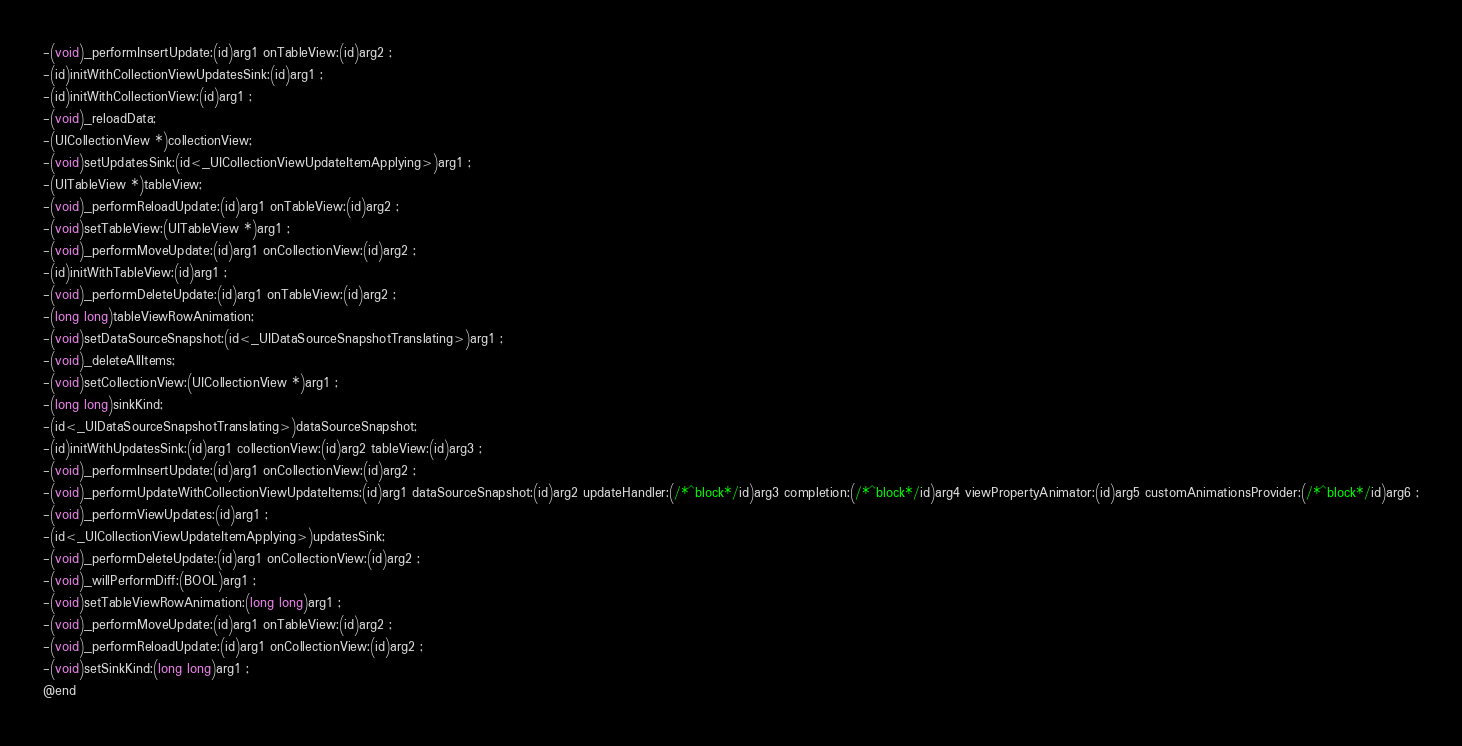Convert code to text. <code><loc_0><loc_0><loc_500><loc_500><_C_>-(void)_performInsertUpdate:(id)arg1 onTableView:(id)arg2 ;
-(id)initWithCollectionViewUpdatesSink:(id)arg1 ;
-(id)initWithCollectionView:(id)arg1 ;
-(void)_reloadData;
-(UICollectionView *)collectionView;
-(void)setUpdatesSink:(id<_UICollectionViewUpdateItemApplying>)arg1 ;
-(UITableView *)tableView;
-(void)_performReloadUpdate:(id)arg1 onTableView:(id)arg2 ;
-(void)setTableView:(UITableView *)arg1 ;
-(void)_performMoveUpdate:(id)arg1 onCollectionView:(id)arg2 ;
-(id)initWithTableView:(id)arg1 ;
-(void)_performDeleteUpdate:(id)arg1 onTableView:(id)arg2 ;
-(long long)tableViewRowAnimation;
-(void)setDataSourceSnapshot:(id<_UIDataSourceSnapshotTranslating>)arg1 ;
-(void)_deleteAllItems;
-(void)setCollectionView:(UICollectionView *)arg1 ;
-(long long)sinkKind;
-(id<_UIDataSourceSnapshotTranslating>)dataSourceSnapshot;
-(id)initWithUpdatesSink:(id)arg1 collectionView:(id)arg2 tableView:(id)arg3 ;
-(void)_performInsertUpdate:(id)arg1 onCollectionView:(id)arg2 ;
-(void)_performUpdateWithCollectionViewUpdateItems:(id)arg1 dataSourceSnapshot:(id)arg2 updateHandler:(/*^block*/id)arg3 completion:(/*^block*/id)arg4 viewPropertyAnimator:(id)arg5 customAnimationsProvider:(/*^block*/id)arg6 ;
-(void)_performViewUpdates:(id)arg1 ;
-(id<_UICollectionViewUpdateItemApplying>)updatesSink;
-(void)_performDeleteUpdate:(id)arg1 onCollectionView:(id)arg2 ;
-(void)_willPerformDiff:(BOOL)arg1 ;
-(void)setTableViewRowAnimation:(long long)arg1 ;
-(void)_performMoveUpdate:(id)arg1 onTableView:(id)arg2 ;
-(void)_performReloadUpdate:(id)arg1 onCollectionView:(id)arg2 ;
-(void)setSinkKind:(long long)arg1 ;
@end

</code> 